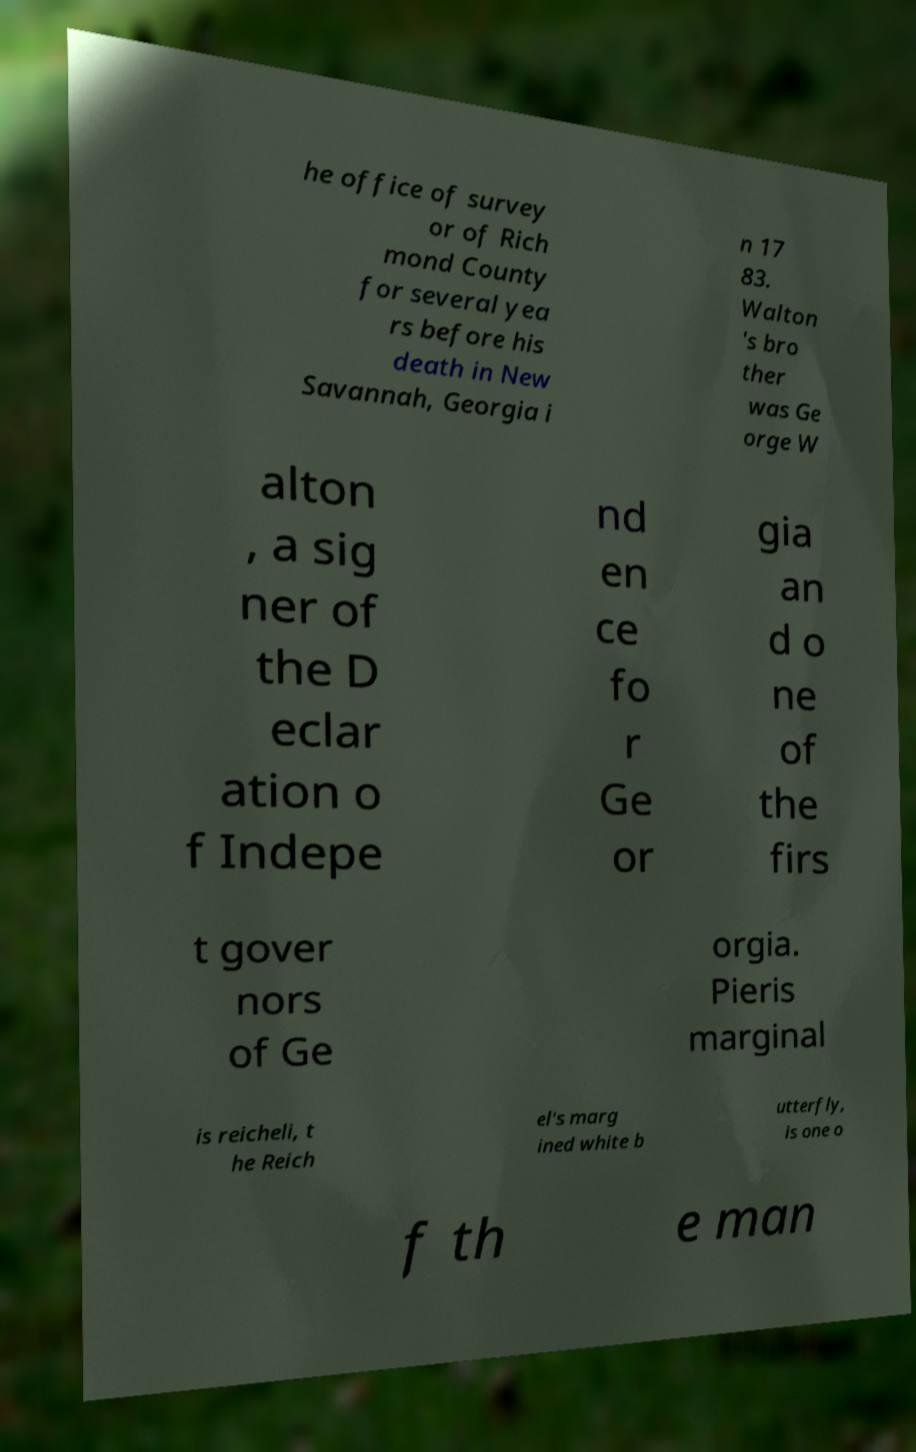There's text embedded in this image that I need extracted. Can you transcribe it verbatim? he office of survey or of Rich mond County for several yea rs before his death in New Savannah, Georgia i n 17 83. Walton 's bro ther was Ge orge W alton , a sig ner of the D eclar ation o f Indepe nd en ce fo r Ge or gia an d o ne of the firs t gover nors of Ge orgia. Pieris marginal is reicheli, t he Reich el's marg ined white b utterfly, is one o f th e man 